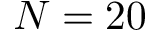Convert formula to latex. <formula><loc_0><loc_0><loc_500><loc_500>N = 2 0</formula> 